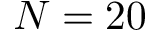Convert formula to latex. <formula><loc_0><loc_0><loc_500><loc_500>N = 2 0</formula> 